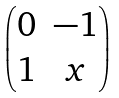Convert formula to latex. <formula><loc_0><loc_0><loc_500><loc_500>\begin{pmatrix} 0 & - 1 \\ 1 & x \end{pmatrix}</formula> 